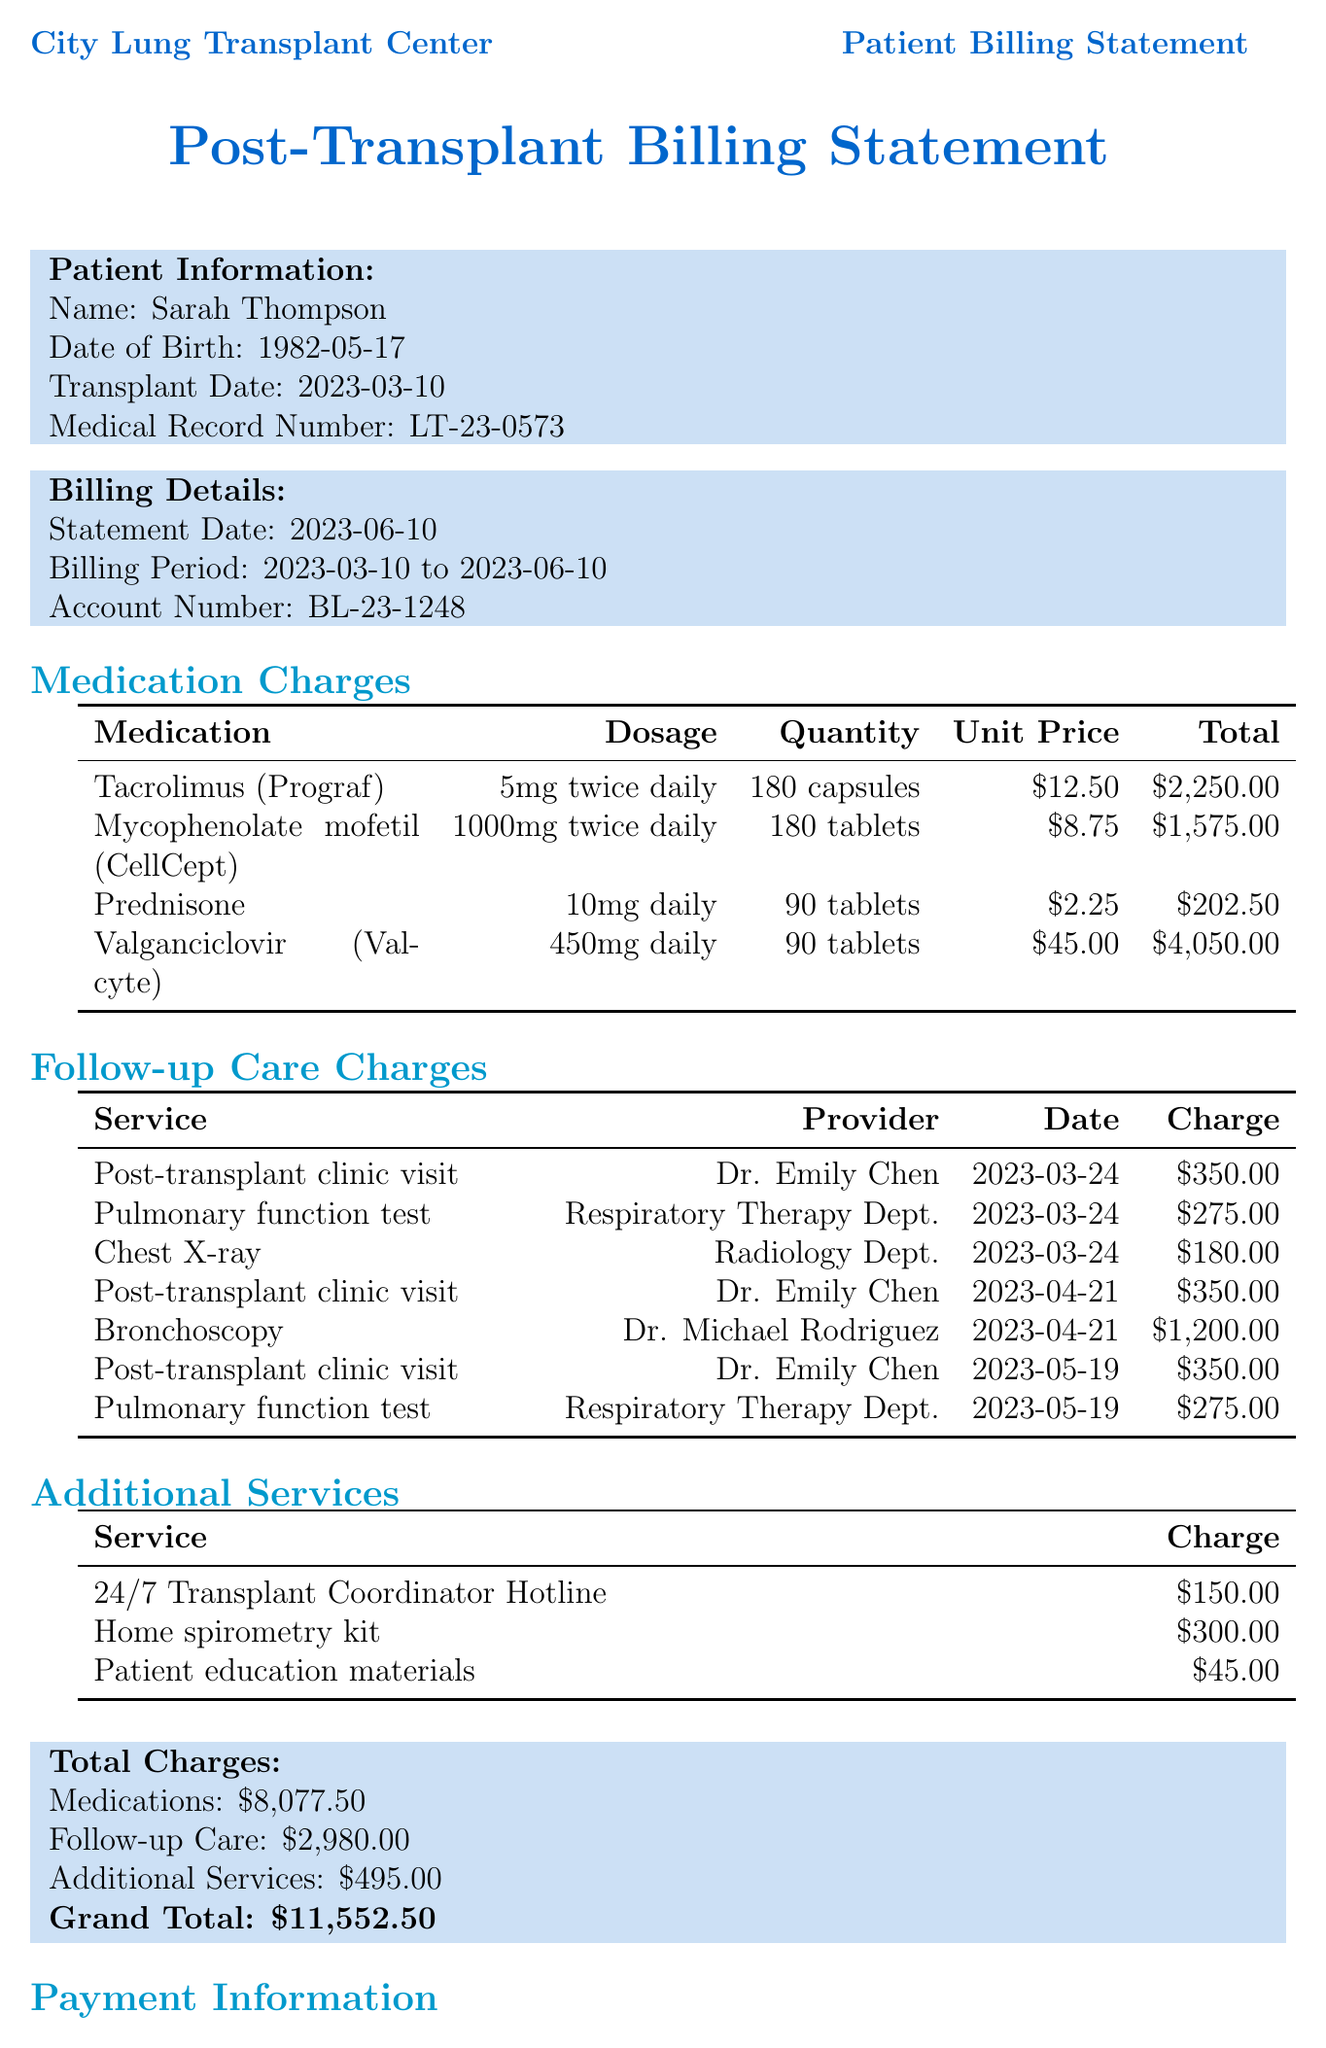what is the patient's name? The patient's name is listed in the patient information section of the document.
Answer: Sarah Thompson what is the medical record number? The medical record number is provided in the patient information section.
Answer: LT-23-0573 what is the total charge for medications? The total charge for medications can be found in the total charges section of the document.
Answer: $8,077.50 how many tablets of Mycophenolate mofetil were charged? The quantity of Mycophenolate mofetil can be retrieved from the medication charges table.
Answer: 180 tablets who provided the chest X-ray service? The provider for the chest X-ray service is indicated in the follow-up care charges table.
Answer: Radiology Dept what was the charge for the bronchoscopy? The bronchoscopy charge is listed in the follow-up care charges section.
Answer: $1,200.00 how many post-transplant clinic visits were charged? The number of post-transplant clinic visits can be determined by counting the entries in the follow-up care charges.
Answer: 3 visits what is the payment due date? The payment due date is provided in the payment information section of the document.
Answer: 2023-07-10 what is the charge for the 24/7 Transplant Coordinator Hotline? The charge for the hotline is stated in the additional services section.
Answer: $150.00 